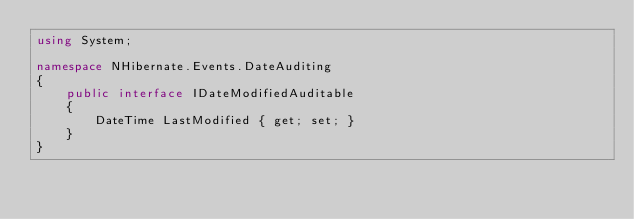<code> <loc_0><loc_0><loc_500><loc_500><_C#_>using System;

namespace NHibernate.Events.DateAuditing
{
    public interface IDateModifiedAuditable
    {
        DateTime LastModified { get; set; }
    }
}</code> 